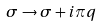<formula> <loc_0><loc_0><loc_500><loc_500>\sigma \rightarrow \sigma + i \pi q</formula> 